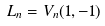Convert formula to latex. <formula><loc_0><loc_0><loc_500><loc_500>L _ { n } = V _ { n } ( 1 , - 1 )</formula> 